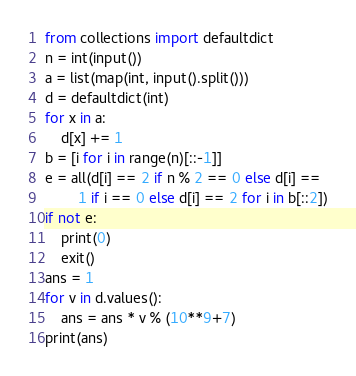<code> <loc_0><loc_0><loc_500><loc_500><_Python_>from collections import defaultdict
n = int(input())
a = list(map(int, input().split()))
d = defaultdict(int)
for x in a:
    d[x] += 1
b = [i for i in range(n)[::-1]]
e = all(d[i] == 2 if n % 2 == 0 else d[i] ==
        1 if i == 0 else d[i] == 2 for i in b[::2])
if not e:
    print(0)
    exit()
ans = 1
for v in d.values():
    ans = ans * v % (10**9+7)
print(ans)
</code> 